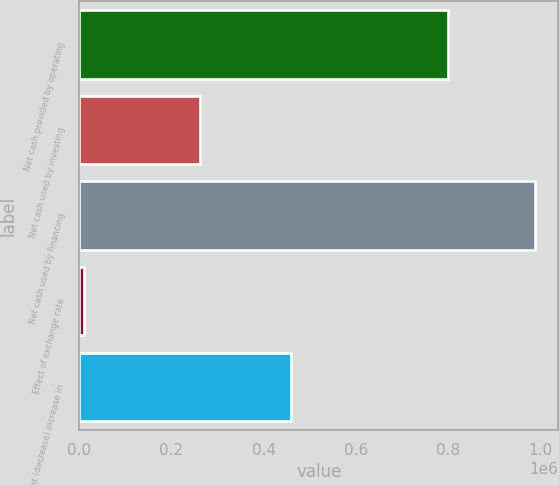Convert chart. <chart><loc_0><loc_0><loc_500><loc_500><bar_chart><fcel>Net cash provided by operating<fcel>Net cash used by investing<fcel>Net cash used by financing<fcel>Effect of exchange rate<fcel>Net (decrease) increase in<nl><fcel>801458<fcel>261311<fcel>990073<fcel>8886<fcel>458812<nl></chart> 